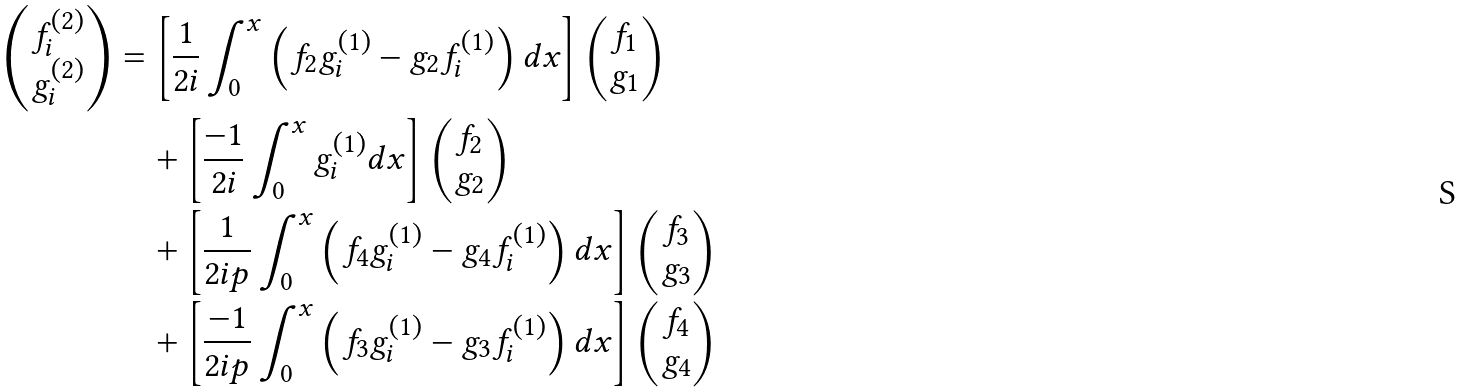Convert formula to latex. <formula><loc_0><loc_0><loc_500><loc_500>\begin{pmatrix} f _ { i } ^ { ( 2 ) } \\ g _ { i } ^ { ( 2 ) } \end{pmatrix} & = \left [ \frac { 1 } { 2 i } \int _ { 0 } ^ { x } \left ( f _ { 2 } g _ { i } ^ { ( 1 ) } - g _ { 2 } f _ { i } ^ { ( 1 ) } \right ) d x \right ] \begin{pmatrix} f _ { 1 } \\ g _ { 1 } \end{pmatrix} \\ & \quad + \left [ \frac { - 1 } { 2 i } \int _ { 0 } ^ { x } g _ { i } ^ { ( 1 ) } d x \right ] \begin{pmatrix} f _ { 2 } \\ g _ { 2 } \end{pmatrix} \\ & \quad + \left [ \frac { 1 } { 2 i p } \int _ { 0 } ^ { x } \left ( f _ { 4 } g _ { i } ^ { ( 1 ) } - g _ { 4 } f _ { i } ^ { ( 1 ) } \right ) d x \right ] \begin{pmatrix} f _ { 3 } \\ g _ { 3 } \end{pmatrix} \\ & \quad + \left [ \frac { - 1 } { 2 i p } \int _ { 0 } ^ { x } \left ( f _ { 3 } g _ { i } ^ { ( 1 ) } - g _ { 3 } f _ { i } ^ { ( 1 ) } \right ) d x \right ] \begin{pmatrix} f _ { 4 } \\ g _ { 4 } \end{pmatrix}</formula> 